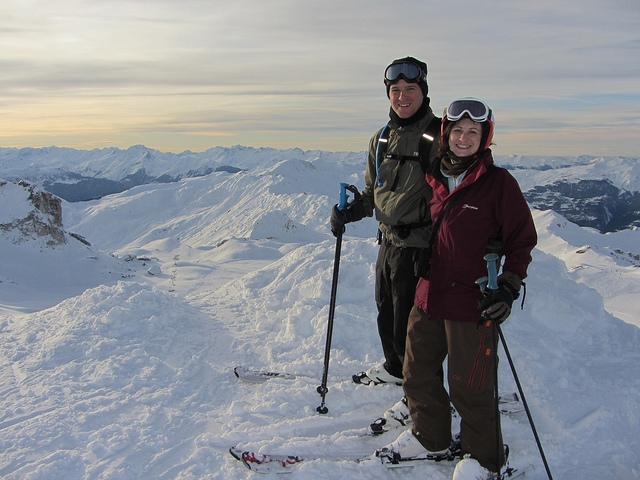<image>What safety precautions are being used? It is not clear what safety precautions are being used as it can include helmets, goggles, gloves, or none at all. What safety precautions are being used? Helmets and goggles are being used as safety precautions. 